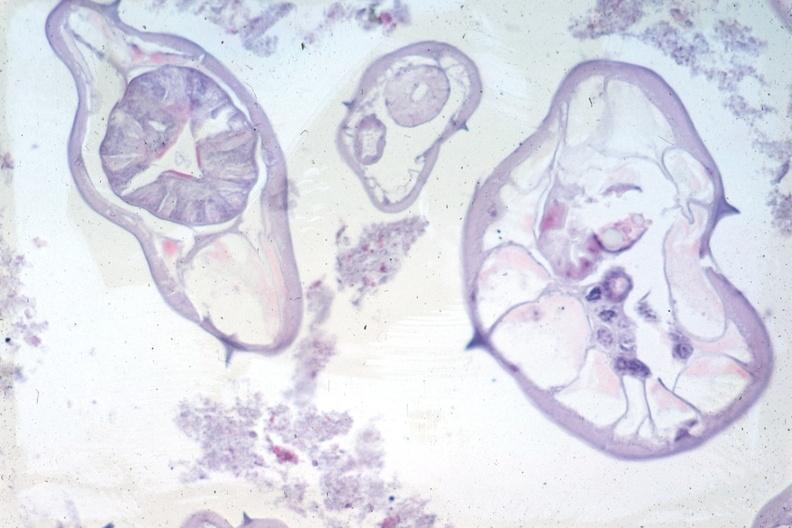does this image show organisms not appendix structures in photo?
Answer the question using a single word or phrase. Yes 